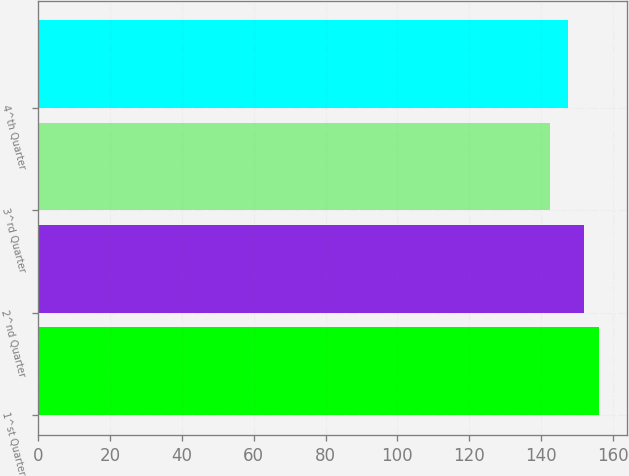Convert chart to OTSL. <chart><loc_0><loc_0><loc_500><loc_500><bar_chart><fcel>1^st Quarter<fcel>2^nd Quarter<fcel>3^rd Quarter<fcel>4^th Quarter<nl><fcel>156.08<fcel>152.02<fcel>142.47<fcel>147.51<nl></chart> 